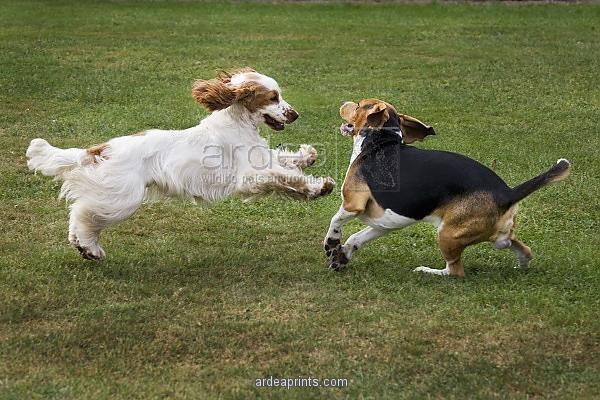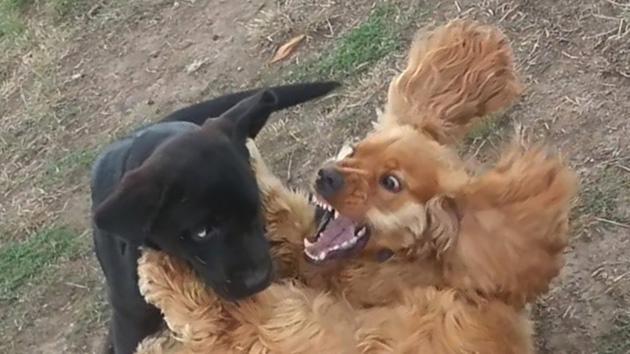The first image is the image on the left, the second image is the image on the right. Analyze the images presented: Is the assertion "The right image contains no more than one dog." valid? Answer yes or no. No. The first image is the image on the left, the second image is the image on the right. Analyze the images presented: Is the assertion "Two dogs are playing in the grass in the left image, and the right image includes an orange spaniel with an open mouth." valid? Answer yes or no. Yes. 